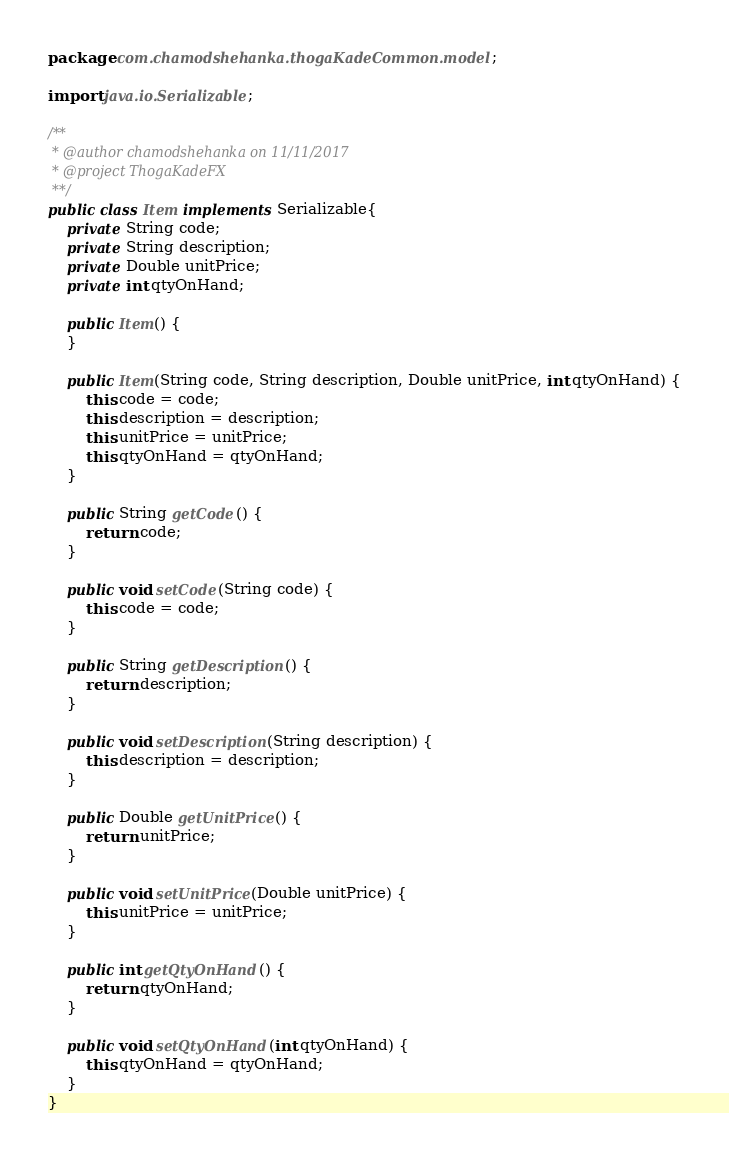<code> <loc_0><loc_0><loc_500><loc_500><_Java_>package com.chamodshehanka.thogaKadeCommon.model;

import java.io.Serializable;

/**
 * @author chamodshehanka on 11/11/2017
 * @project ThogaKadeFX
 **/
public class Item implements Serializable{
    private String code;
    private String description;
    private Double unitPrice;
    private int qtyOnHand;

    public Item() {
    }

    public Item(String code, String description, Double unitPrice, int qtyOnHand) {
        this.code = code;
        this.description = description;
        this.unitPrice = unitPrice;
        this.qtyOnHand = qtyOnHand;
    }

    public String getCode() {
        return code;
    }

    public void setCode(String code) {
        this.code = code;
    }

    public String getDescription() {
        return description;
    }

    public void setDescription(String description) {
        this.description = description;
    }

    public Double getUnitPrice() {
        return unitPrice;
    }

    public void setUnitPrice(Double unitPrice) {
        this.unitPrice = unitPrice;
    }

    public int getQtyOnHand() {
        return qtyOnHand;
    }

    public void setQtyOnHand(int qtyOnHand) {
        this.qtyOnHand = qtyOnHand;
    }
}
</code> 